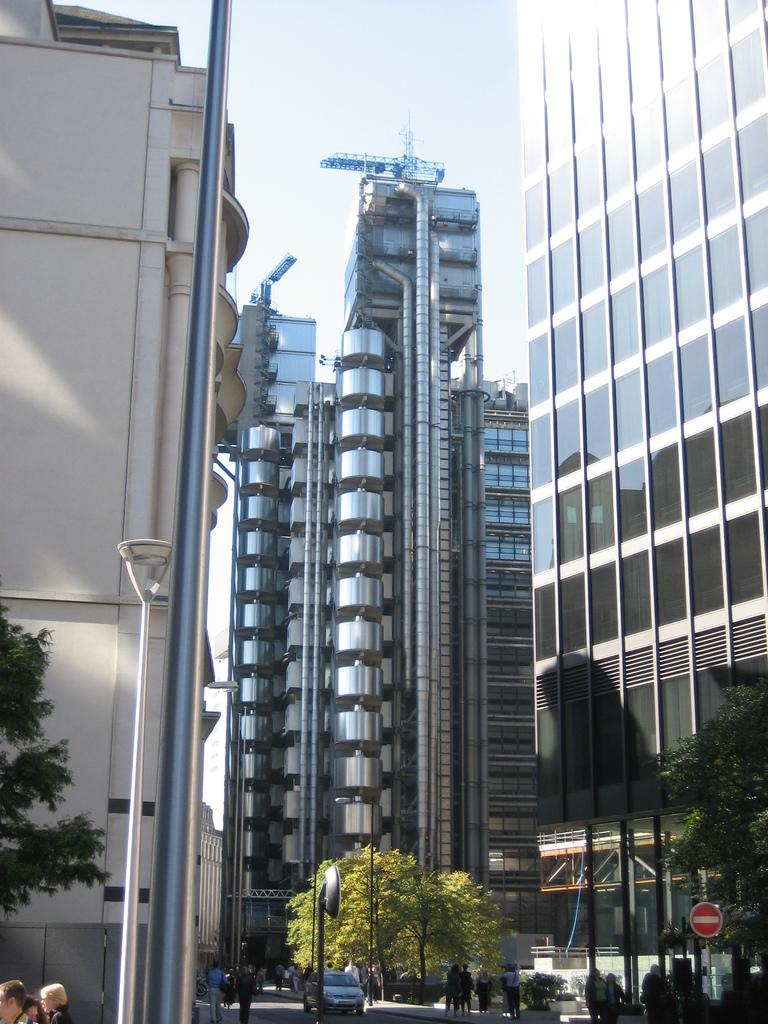What type of structures can be seen in the image? There are buildings in the image. What other objects are present in the image? There are poles, trees, people, boards, plants, and a light in the image. What can be seen in the background of the image? The sky is visible in the background of the image. What type of credit can be seen being given to the people in the image? There is no credit being given to the people in the image; it is a still image and does not depict any transactions or interactions involving credit. What type of curve can be seen in the image? There is no curve present in the image; the objects and structures depicted are mostly straight or angular. 